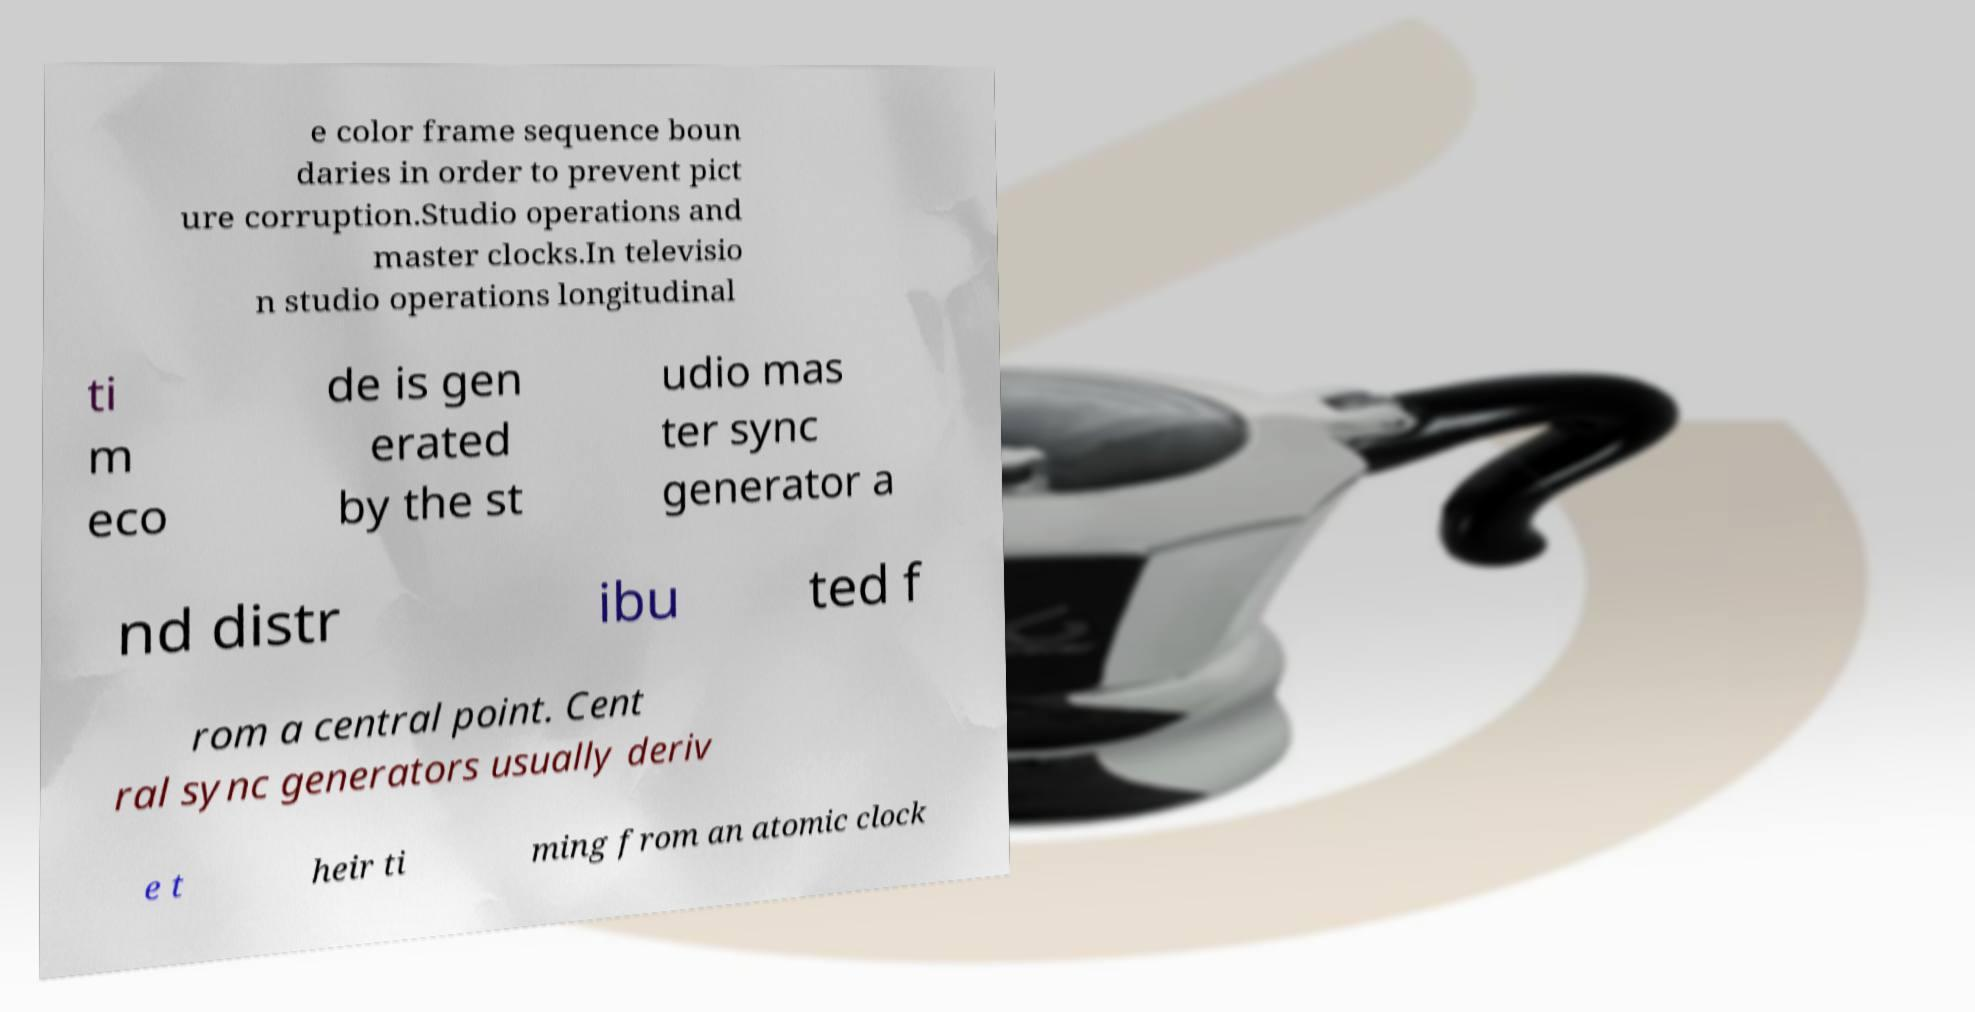Can you read and provide the text displayed in the image?This photo seems to have some interesting text. Can you extract and type it out for me? e color frame sequence boun daries in order to prevent pict ure corruption.Studio operations and master clocks.In televisio n studio operations longitudinal ti m eco de is gen erated by the st udio mas ter sync generator a nd distr ibu ted f rom a central point. Cent ral sync generators usually deriv e t heir ti ming from an atomic clock 